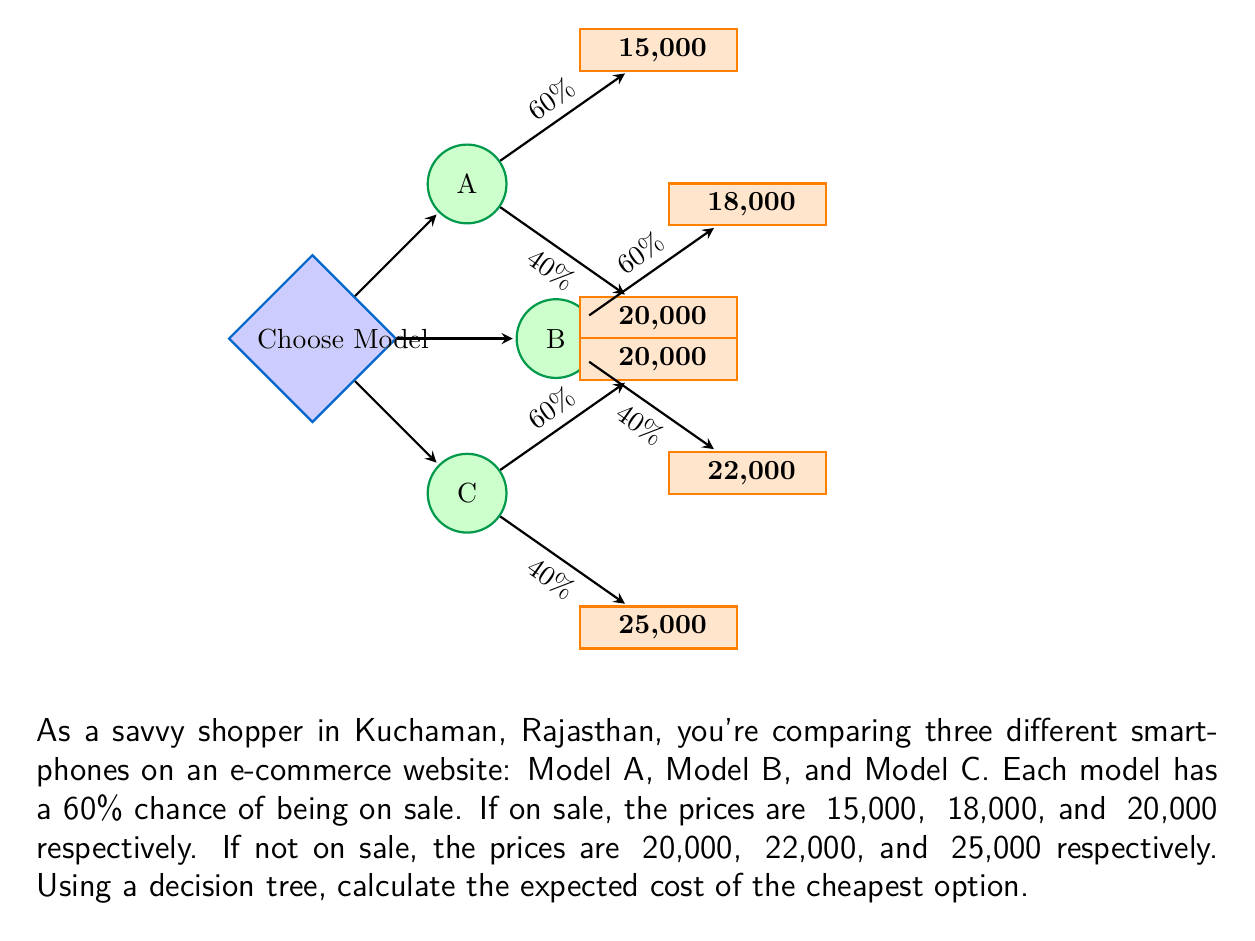Help me with this question. Let's calculate the expected cost for each model using the decision tree:

1. For Model A:
   Expected cost = (0.60 × ₹15,000) + (0.40 × ₹20,000)
   $$ E(A) = 0.60 \times 15000 + 0.40 \times 20000 = 9000 + 8000 = ₹17,000 $$

2. For Model B:
   Expected cost = (0.60 × ₹18,000) + (0.40 × ₹22,000)
   $$ E(B) = 0.60 \times 18000 + 0.40 \times 22000 = 10800 + 8800 = ₹19,600 $$

3. For Model C:
   Expected cost = (0.60 × ₹20,000) + (0.40 × ₹25,000)
   $$ E(C) = 0.60 \times 20000 + 0.40 \times 25000 = 12000 + 10000 = ₹22,000 $$

The cheapest option is the one with the lowest expected cost. Comparing the three expected costs:

$$ E(A) = ₹17,000 < E(B) = ₹19,600 < E(C) = ₹22,000 $$

Therefore, Model A has the lowest expected cost of ₹17,000.
Answer: ₹17,000 